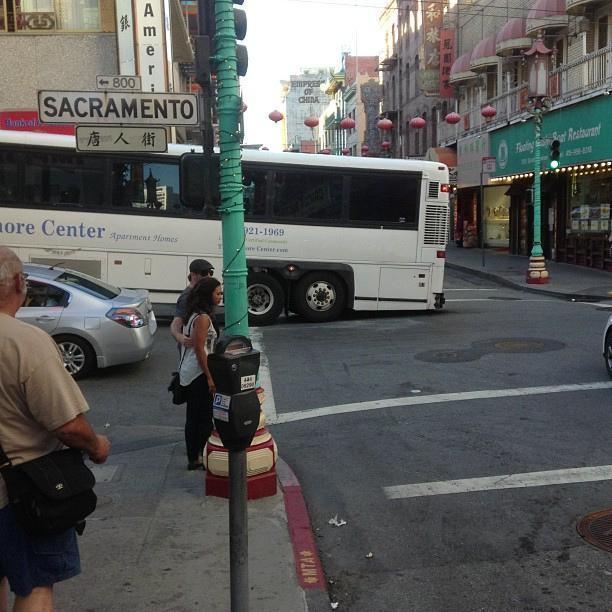How many people in the shot?
Give a very brief answer. 3. How many people are in the photo?
Give a very brief answer. 2. How many trees behind the elephants are in the image?
Give a very brief answer. 0. 